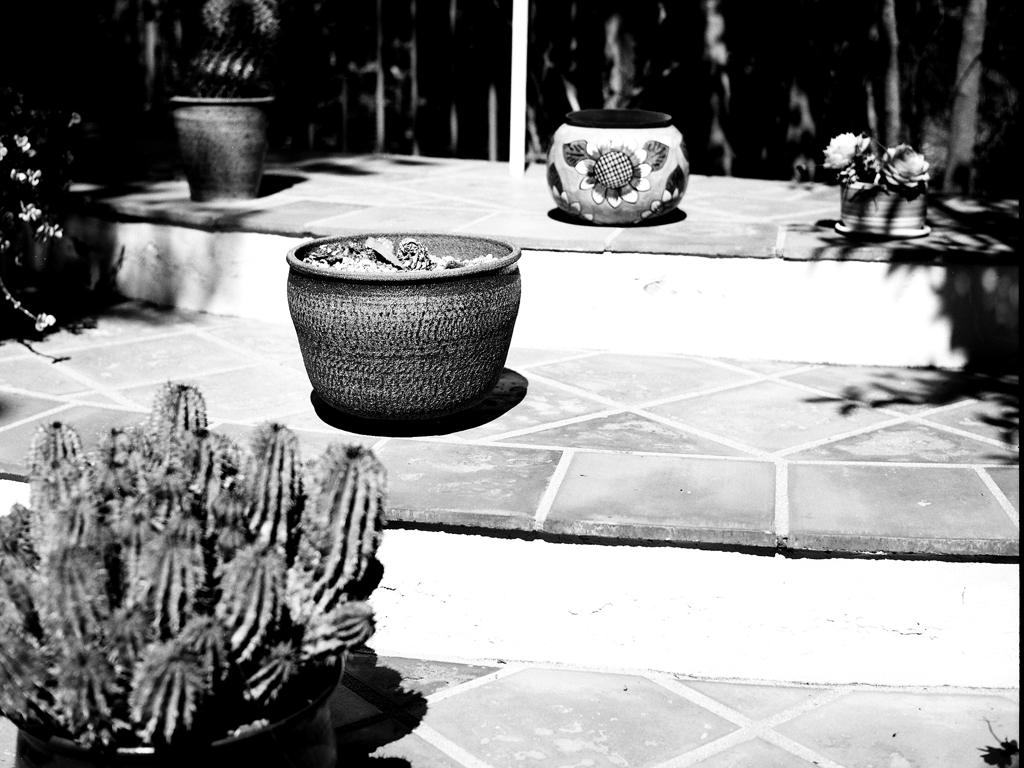Can you describe the types of plants seen in this image? The image displays a variety of potted plants including cacti and what appears to be succulents. The cactus in the forefront has prominent ridges and is likely adapted to arid environments. In the background, one pot features painted designs which suggests a touch of human creativity often associated with garden decor. 